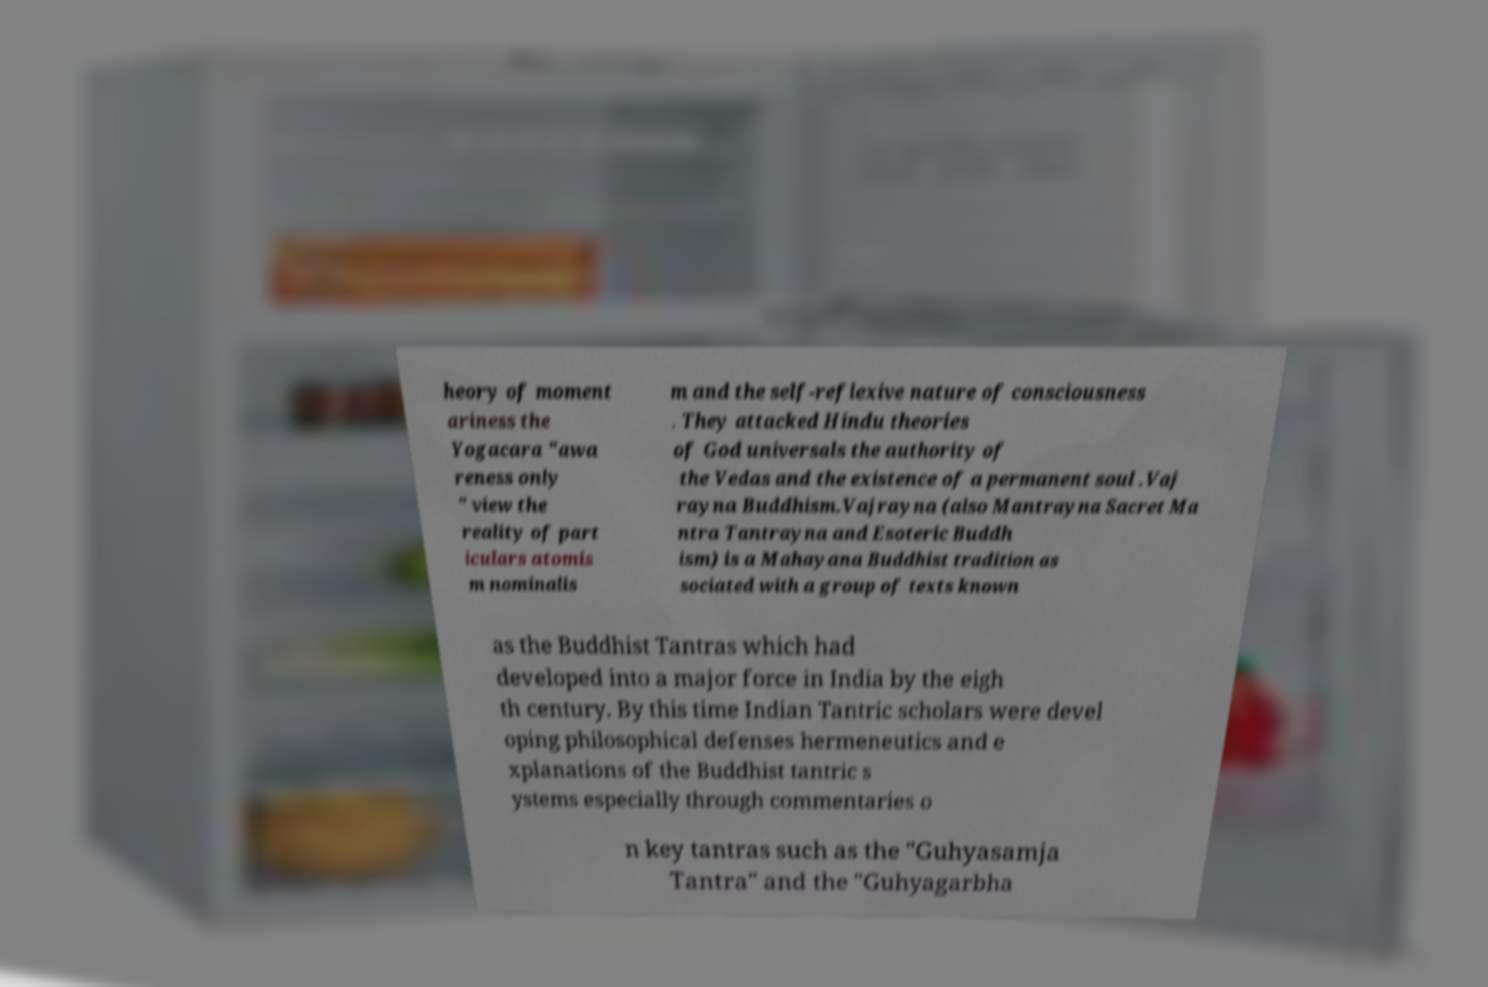Could you assist in decoding the text presented in this image and type it out clearly? heory of moment ariness the Yogacara "awa reness only " view the reality of part iculars atomis m nominalis m and the self-reflexive nature of consciousness . They attacked Hindu theories of God universals the authority of the Vedas and the existence of a permanent soul .Vaj rayna Buddhism.Vajrayna (also Mantrayna Sacret Ma ntra Tantrayna and Esoteric Buddh ism) is a Mahayana Buddhist tradition as sociated with a group of texts known as the Buddhist Tantras which had developed into a major force in India by the eigh th century. By this time Indian Tantric scholars were devel oping philosophical defenses hermeneutics and e xplanations of the Buddhist tantric s ystems especially through commentaries o n key tantras such as the "Guhyasamja Tantra" and the "Guhyagarbha 